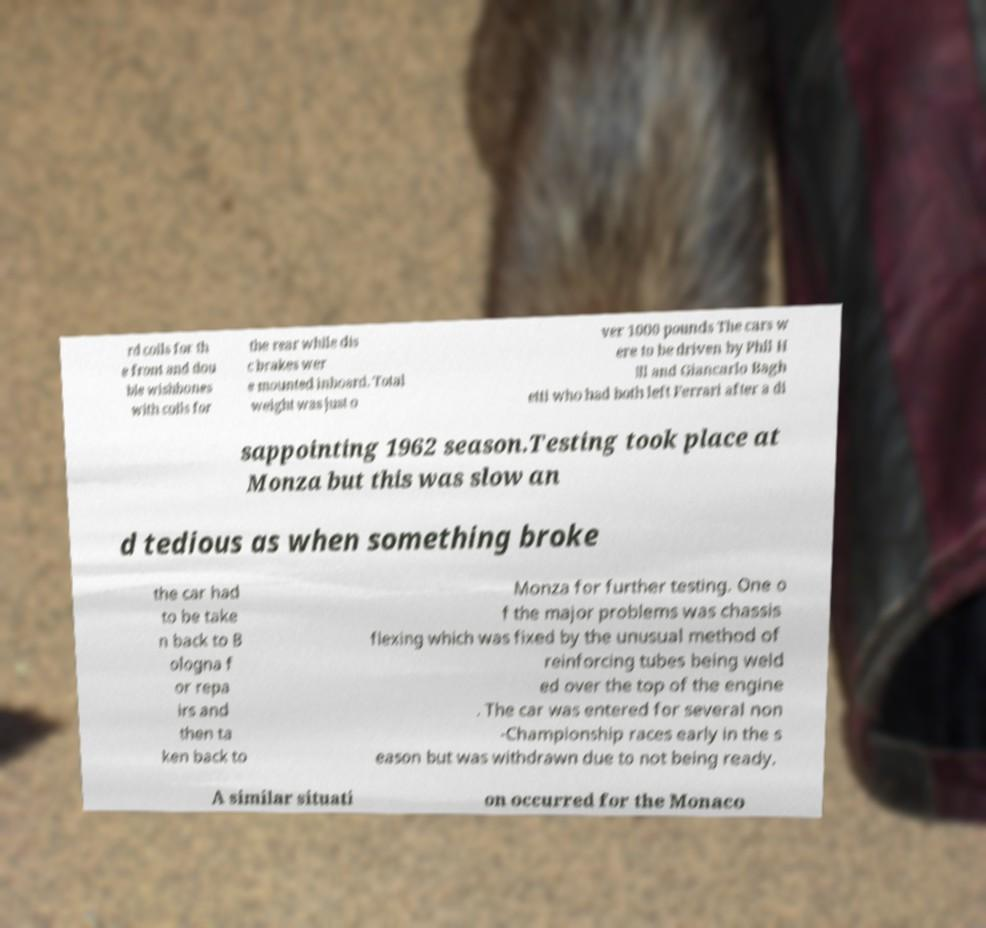I need the written content from this picture converted into text. Can you do that? rd coils for th e front and dou ble wishbones with coils for the rear while dis c brakes wer e mounted inboard. Total weight was just o ver 1000 pounds The cars w ere to be driven by Phil H ill and Giancarlo Bagh etti who had both left Ferrari after a di sappointing 1962 season.Testing took place at Monza but this was slow an d tedious as when something broke the car had to be take n back to B ologna f or repa irs and then ta ken back to Monza for further testing. One o f the major problems was chassis flexing which was fixed by the unusual method of reinforcing tubes being weld ed over the top of the engine . The car was entered for several non -Championship races early in the s eason but was withdrawn due to not being ready. A similar situati on occurred for the Monaco 